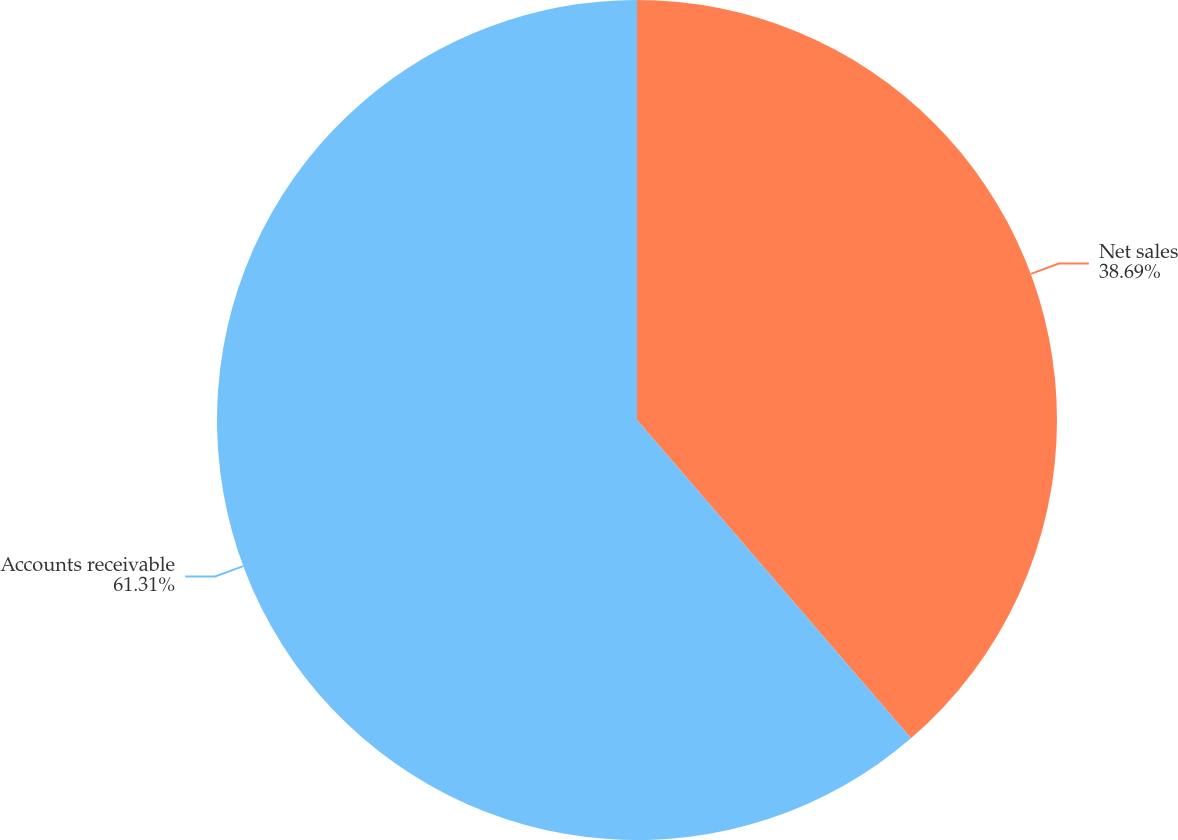Convert chart. <chart><loc_0><loc_0><loc_500><loc_500><pie_chart><fcel>Net sales<fcel>Accounts receivable<nl><fcel>38.69%<fcel>61.31%<nl></chart> 